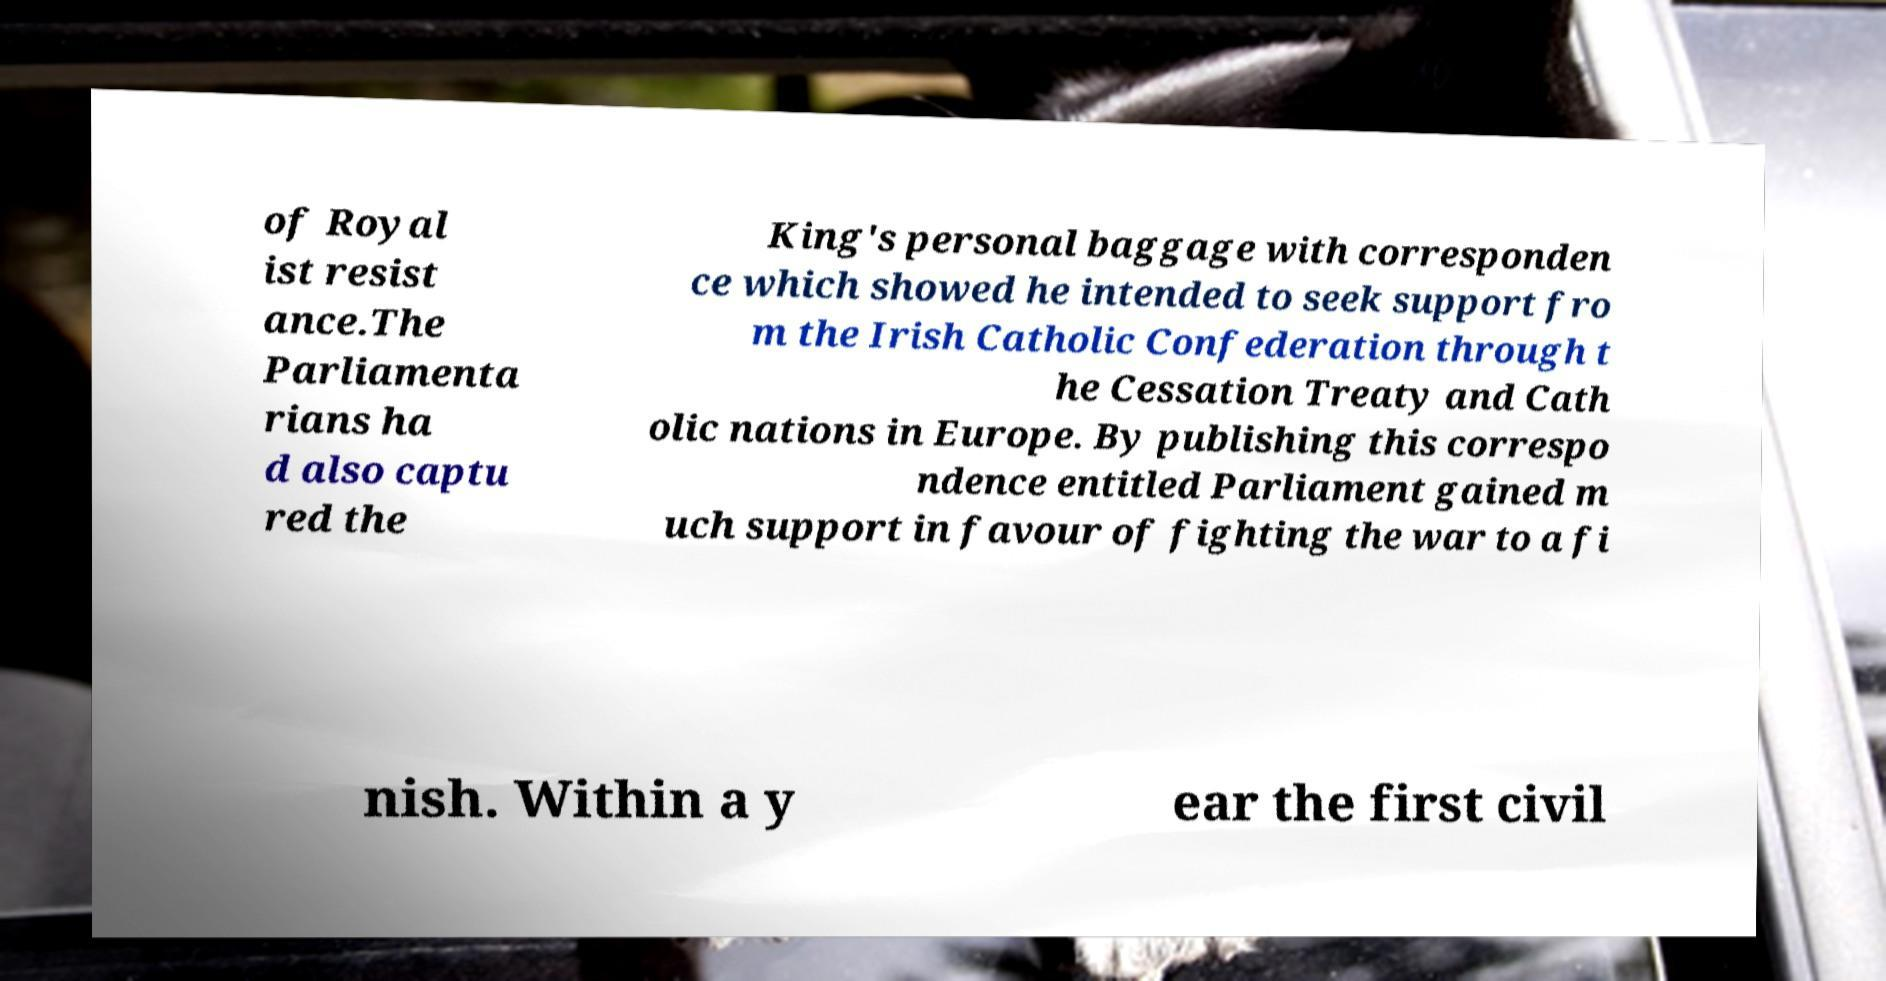Please identify and transcribe the text found in this image. of Royal ist resist ance.The Parliamenta rians ha d also captu red the King's personal baggage with corresponden ce which showed he intended to seek support fro m the Irish Catholic Confederation through t he Cessation Treaty and Cath olic nations in Europe. By publishing this correspo ndence entitled Parliament gained m uch support in favour of fighting the war to a fi nish. Within a y ear the first civil 